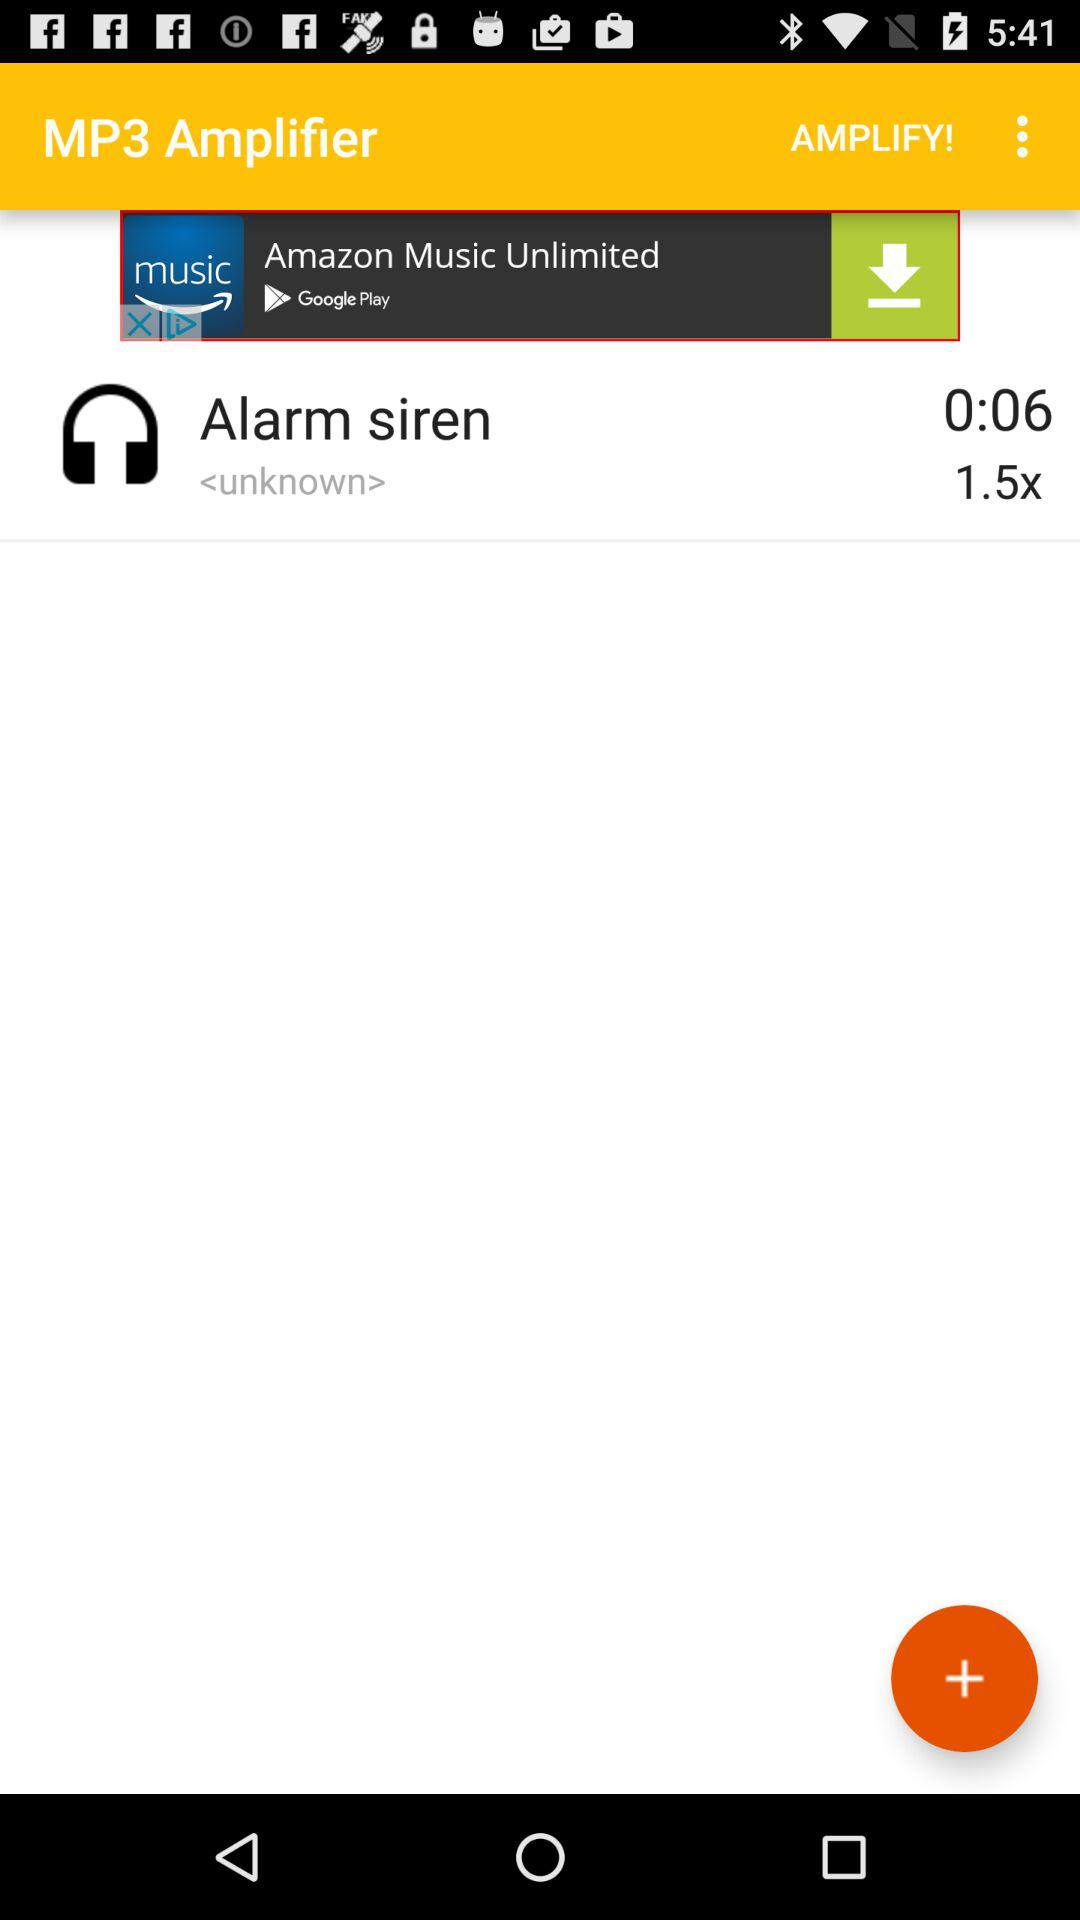What is the duration of the alarm siren? The duration is 0:06. 